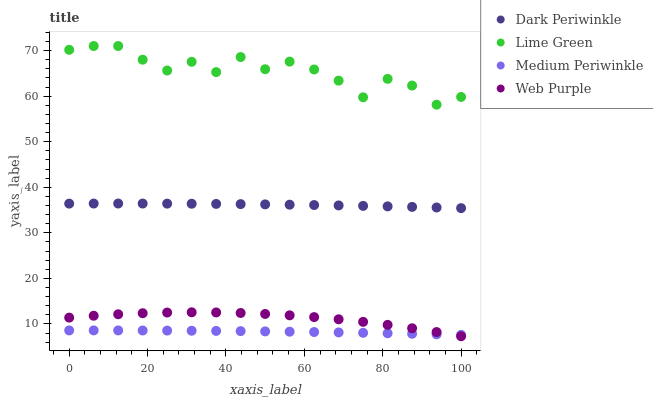Does Medium Periwinkle have the minimum area under the curve?
Answer yes or no. Yes. Does Lime Green have the maximum area under the curve?
Answer yes or no. Yes. Does Web Purple have the minimum area under the curve?
Answer yes or no. No. Does Web Purple have the maximum area under the curve?
Answer yes or no. No. Is Medium Periwinkle the smoothest?
Answer yes or no. Yes. Is Lime Green the roughest?
Answer yes or no. Yes. Is Web Purple the smoothest?
Answer yes or no. No. Is Web Purple the roughest?
Answer yes or no. No. Does Web Purple have the lowest value?
Answer yes or no. Yes. Does Lime Green have the lowest value?
Answer yes or no. No. Does Lime Green have the highest value?
Answer yes or no. Yes. Does Web Purple have the highest value?
Answer yes or no. No. Is Medium Periwinkle less than Lime Green?
Answer yes or no. Yes. Is Lime Green greater than Web Purple?
Answer yes or no. Yes. Does Web Purple intersect Medium Periwinkle?
Answer yes or no. Yes. Is Web Purple less than Medium Periwinkle?
Answer yes or no. No. Is Web Purple greater than Medium Periwinkle?
Answer yes or no. No. Does Medium Periwinkle intersect Lime Green?
Answer yes or no. No. 